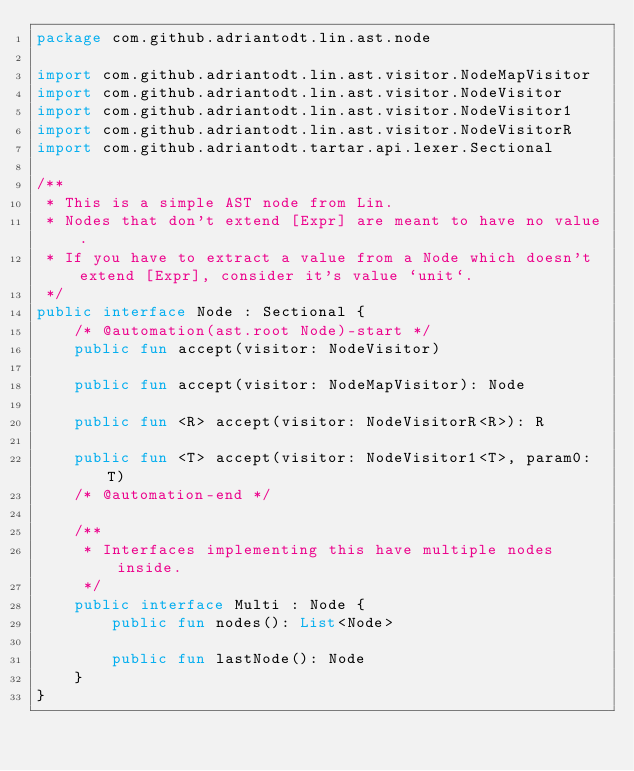<code> <loc_0><loc_0><loc_500><loc_500><_Kotlin_>package com.github.adriantodt.lin.ast.node

import com.github.adriantodt.lin.ast.visitor.NodeMapVisitor
import com.github.adriantodt.lin.ast.visitor.NodeVisitor
import com.github.adriantodt.lin.ast.visitor.NodeVisitor1
import com.github.adriantodt.lin.ast.visitor.NodeVisitorR
import com.github.adriantodt.tartar.api.lexer.Sectional

/**
 * This is a simple AST node from Lin.
 * Nodes that don't extend [Expr] are meant to have no value.
 * If you have to extract a value from a Node which doesn't extend [Expr], consider it's value `unit`.
 */
public interface Node : Sectional {
    /* @automation(ast.root Node)-start */
    public fun accept(visitor: NodeVisitor)

    public fun accept(visitor: NodeMapVisitor): Node

    public fun <R> accept(visitor: NodeVisitorR<R>): R

    public fun <T> accept(visitor: NodeVisitor1<T>, param0: T)
    /* @automation-end */

    /**
     * Interfaces implementing this have multiple nodes inside.
     */
    public interface Multi : Node {
        public fun nodes(): List<Node>

        public fun lastNode(): Node
    }
}
</code> 